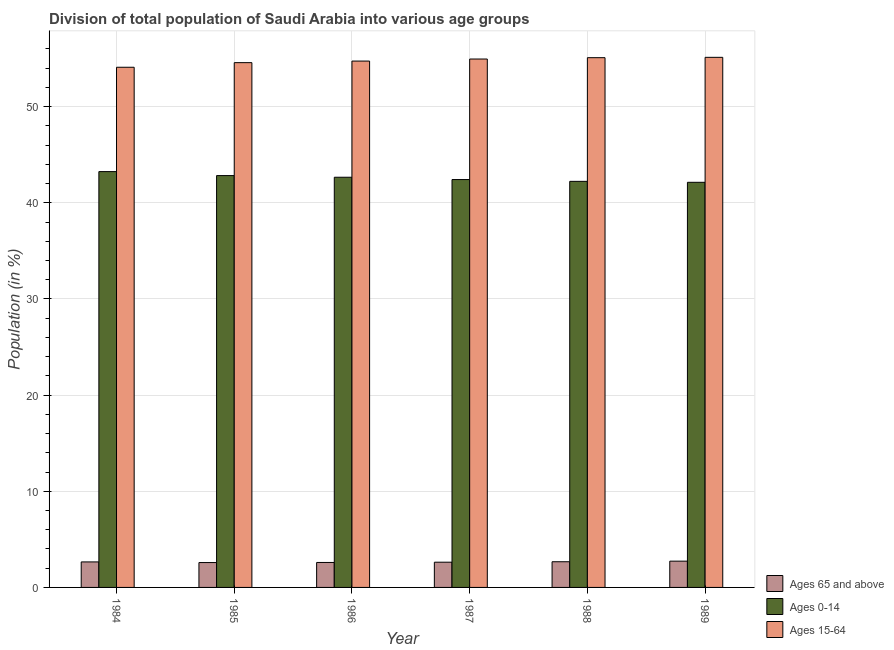Are the number of bars per tick equal to the number of legend labels?
Provide a short and direct response. Yes. How many bars are there on the 4th tick from the left?
Ensure brevity in your answer.  3. How many bars are there on the 3rd tick from the right?
Offer a very short reply. 3. In how many cases, is the number of bars for a given year not equal to the number of legend labels?
Offer a terse response. 0. What is the percentage of population within the age-group of 65 and above in 1984?
Offer a terse response. 2.65. Across all years, what is the maximum percentage of population within the age-group 0-14?
Give a very brief answer. 43.25. Across all years, what is the minimum percentage of population within the age-group 0-14?
Provide a succinct answer. 42.13. In which year was the percentage of population within the age-group 15-64 minimum?
Provide a short and direct response. 1984. What is the total percentage of population within the age-group of 65 and above in the graph?
Offer a very short reply. 15.86. What is the difference between the percentage of population within the age-group of 65 and above in 1984 and that in 1988?
Your response must be concise. -0.02. What is the difference between the percentage of population within the age-group of 65 and above in 1985 and the percentage of population within the age-group 15-64 in 1987?
Offer a terse response. -0.04. What is the average percentage of population within the age-group of 65 and above per year?
Provide a short and direct response. 2.64. In how many years, is the percentage of population within the age-group of 65 and above greater than 22 %?
Your answer should be compact. 0. What is the ratio of the percentage of population within the age-group 15-64 in 1987 to that in 1988?
Your answer should be very brief. 1. Is the difference between the percentage of population within the age-group 15-64 in 1987 and 1988 greater than the difference between the percentage of population within the age-group 0-14 in 1987 and 1988?
Your answer should be very brief. No. What is the difference between the highest and the second highest percentage of population within the age-group 15-64?
Keep it short and to the point. 0.04. What is the difference between the highest and the lowest percentage of population within the age-group 15-64?
Offer a very short reply. 1.03. In how many years, is the percentage of population within the age-group of 65 and above greater than the average percentage of population within the age-group of 65 and above taken over all years?
Give a very brief answer. 3. Is the sum of the percentage of population within the age-group 0-14 in 1987 and 1989 greater than the maximum percentage of population within the age-group of 65 and above across all years?
Make the answer very short. Yes. What does the 1st bar from the left in 1986 represents?
Make the answer very short. Ages 65 and above. What does the 1st bar from the right in 1987 represents?
Give a very brief answer. Ages 15-64. Is it the case that in every year, the sum of the percentage of population within the age-group of 65 and above and percentage of population within the age-group 0-14 is greater than the percentage of population within the age-group 15-64?
Your answer should be compact. No. Are all the bars in the graph horizontal?
Provide a succinct answer. No. Are the values on the major ticks of Y-axis written in scientific E-notation?
Your answer should be compact. No. Does the graph contain any zero values?
Make the answer very short. No. Does the graph contain grids?
Offer a very short reply. Yes. How are the legend labels stacked?
Make the answer very short. Vertical. What is the title of the graph?
Provide a short and direct response. Division of total population of Saudi Arabia into various age groups
. Does "Agricultural raw materials" appear as one of the legend labels in the graph?
Make the answer very short. No. What is the label or title of the X-axis?
Provide a succinct answer. Year. What is the Population (in %) in Ages 65 and above in 1984?
Your response must be concise. 2.65. What is the Population (in %) in Ages 0-14 in 1984?
Offer a terse response. 43.25. What is the Population (in %) of Ages 15-64 in 1984?
Offer a terse response. 54.1. What is the Population (in %) in Ages 65 and above in 1985?
Your answer should be compact. 2.59. What is the Population (in %) in Ages 0-14 in 1985?
Provide a short and direct response. 42.83. What is the Population (in %) in Ages 15-64 in 1985?
Offer a terse response. 54.58. What is the Population (in %) in Ages 65 and above in 1986?
Keep it short and to the point. 2.6. What is the Population (in %) in Ages 0-14 in 1986?
Offer a terse response. 42.66. What is the Population (in %) in Ages 15-64 in 1986?
Ensure brevity in your answer.  54.74. What is the Population (in %) in Ages 65 and above in 1987?
Offer a terse response. 2.62. What is the Population (in %) of Ages 0-14 in 1987?
Make the answer very short. 42.42. What is the Population (in %) of Ages 15-64 in 1987?
Offer a terse response. 54.96. What is the Population (in %) of Ages 65 and above in 1988?
Keep it short and to the point. 2.67. What is the Population (in %) in Ages 0-14 in 1988?
Make the answer very short. 42.23. What is the Population (in %) in Ages 15-64 in 1988?
Provide a short and direct response. 55.1. What is the Population (in %) of Ages 65 and above in 1989?
Offer a terse response. 2.73. What is the Population (in %) of Ages 0-14 in 1989?
Your answer should be compact. 42.13. What is the Population (in %) of Ages 15-64 in 1989?
Provide a succinct answer. 55.13. Across all years, what is the maximum Population (in %) of Ages 65 and above?
Your answer should be compact. 2.73. Across all years, what is the maximum Population (in %) of Ages 0-14?
Make the answer very short. 43.25. Across all years, what is the maximum Population (in %) of Ages 15-64?
Keep it short and to the point. 55.13. Across all years, what is the minimum Population (in %) of Ages 65 and above?
Offer a terse response. 2.59. Across all years, what is the minimum Population (in %) in Ages 0-14?
Offer a terse response. 42.13. Across all years, what is the minimum Population (in %) in Ages 15-64?
Your response must be concise. 54.1. What is the total Population (in %) of Ages 65 and above in the graph?
Your response must be concise. 15.86. What is the total Population (in %) in Ages 0-14 in the graph?
Your answer should be compact. 255.53. What is the total Population (in %) in Ages 15-64 in the graph?
Offer a very short reply. 328.61. What is the difference between the Population (in %) in Ages 65 and above in 1984 and that in 1985?
Your response must be concise. 0.07. What is the difference between the Population (in %) in Ages 0-14 in 1984 and that in 1985?
Give a very brief answer. 0.41. What is the difference between the Population (in %) in Ages 15-64 in 1984 and that in 1985?
Make the answer very short. -0.48. What is the difference between the Population (in %) of Ages 65 and above in 1984 and that in 1986?
Your response must be concise. 0.06. What is the difference between the Population (in %) of Ages 0-14 in 1984 and that in 1986?
Your response must be concise. 0.59. What is the difference between the Population (in %) of Ages 15-64 in 1984 and that in 1986?
Offer a terse response. -0.64. What is the difference between the Population (in %) in Ages 65 and above in 1984 and that in 1987?
Offer a terse response. 0.03. What is the difference between the Population (in %) in Ages 0-14 in 1984 and that in 1987?
Offer a terse response. 0.83. What is the difference between the Population (in %) of Ages 15-64 in 1984 and that in 1987?
Provide a succinct answer. -0.86. What is the difference between the Population (in %) of Ages 65 and above in 1984 and that in 1988?
Provide a short and direct response. -0.02. What is the difference between the Population (in %) of Ages 0-14 in 1984 and that in 1988?
Provide a succinct answer. 1.01. What is the difference between the Population (in %) in Ages 15-64 in 1984 and that in 1988?
Provide a short and direct response. -0.99. What is the difference between the Population (in %) of Ages 65 and above in 1984 and that in 1989?
Provide a short and direct response. -0.08. What is the difference between the Population (in %) in Ages 0-14 in 1984 and that in 1989?
Keep it short and to the point. 1.11. What is the difference between the Population (in %) in Ages 15-64 in 1984 and that in 1989?
Ensure brevity in your answer.  -1.03. What is the difference between the Population (in %) of Ages 65 and above in 1985 and that in 1986?
Make the answer very short. -0.01. What is the difference between the Population (in %) in Ages 0-14 in 1985 and that in 1986?
Your response must be concise. 0.17. What is the difference between the Population (in %) in Ages 15-64 in 1985 and that in 1986?
Your response must be concise. -0.16. What is the difference between the Population (in %) of Ages 65 and above in 1985 and that in 1987?
Provide a succinct answer. -0.04. What is the difference between the Population (in %) in Ages 0-14 in 1985 and that in 1987?
Ensure brevity in your answer.  0.41. What is the difference between the Population (in %) in Ages 15-64 in 1985 and that in 1987?
Make the answer very short. -0.38. What is the difference between the Population (in %) in Ages 65 and above in 1985 and that in 1988?
Your answer should be very brief. -0.08. What is the difference between the Population (in %) in Ages 0-14 in 1985 and that in 1988?
Your answer should be compact. 0.6. What is the difference between the Population (in %) in Ages 15-64 in 1985 and that in 1988?
Give a very brief answer. -0.52. What is the difference between the Population (in %) of Ages 65 and above in 1985 and that in 1989?
Provide a short and direct response. -0.15. What is the difference between the Population (in %) in Ages 0-14 in 1985 and that in 1989?
Your answer should be compact. 0.7. What is the difference between the Population (in %) of Ages 15-64 in 1985 and that in 1989?
Provide a succinct answer. -0.55. What is the difference between the Population (in %) in Ages 65 and above in 1986 and that in 1987?
Your answer should be compact. -0.03. What is the difference between the Population (in %) in Ages 0-14 in 1986 and that in 1987?
Provide a short and direct response. 0.24. What is the difference between the Population (in %) of Ages 15-64 in 1986 and that in 1987?
Give a very brief answer. -0.21. What is the difference between the Population (in %) in Ages 65 and above in 1986 and that in 1988?
Your answer should be very brief. -0.08. What is the difference between the Population (in %) of Ages 0-14 in 1986 and that in 1988?
Offer a very short reply. 0.43. What is the difference between the Population (in %) of Ages 15-64 in 1986 and that in 1988?
Ensure brevity in your answer.  -0.35. What is the difference between the Population (in %) of Ages 65 and above in 1986 and that in 1989?
Keep it short and to the point. -0.14. What is the difference between the Population (in %) in Ages 0-14 in 1986 and that in 1989?
Offer a very short reply. 0.53. What is the difference between the Population (in %) in Ages 15-64 in 1986 and that in 1989?
Your response must be concise. -0.39. What is the difference between the Population (in %) in Ages 65 and above in 1987 and that in 1988?
Ensure brevity in your answer.  -0.05. What is the difference between the Population (in %) in Ages 0-14 in 1987 and that in 1988?
Offer a very short reply. 0.19. What is the difference between the Population (in %) in Ages 15-64 in 1987 and that in 1988?
Your answer should be compact. -0.14. What is the difference between the Population (in %) in Ages 65 and above in 1987 and that in 1989?
Offer a very short reply. -0.11. What is the difference between the Population (in %) in Ages 0-14 in 1987 and that in 1989?
Keep it short and to the point. 0.28. What is the difference between the Population (in %) of Ages 15-64 in 1987 and that in 1989?
Your response must be concise. -0.18. What is the difference between the Population (in %) of Ages 65 and above in 1988 and that in 1989?
Your answer should be very brief. -0.06. What is the difference between the Population (in %) of Ages 0-14 in 1988 and that in 1989?
Make the answer very short. 0.1. What is the difference between the Population (in %) of Ages 15-64 in 1988 and that in 1989?
Give a very brief answer. -0.04. What is the difference between the Population (in %) of Ages 65 and above in 1984 and the Population (in %) of Ages 0-14 in 1985?
Your response must be concise. -40.18. What is the difference between the Population (in %) in Ages 65 and above in 1984 and the Population (in %) in Ages 15-64 in 1985?
Offer a terse response. -51.93. What is the difference between the Population (in %) of Ages 0-14 in 1984 and the Population (in %) of Ages 15-64 in 1985?
Offer a very short reply. -11.33. What is the difference between the Population (in %) of Ages 65 and above in 1984 and the Population (in %) of Ages 0-14 in 1986?
Your response must be concise. -40.01. What is the difference between the Population (in %) of Ages 65 and above in 1984 and the Population (in %) of Ages 15-64 in 1986?
Your answer should be compact. -52.09. What is the difference between the Population (in %) in Ages 0-14 in 1984 and the Population (in %) in Ages 15-64 in 1986?
Your answer should be very brief. -11.5. What is the difference between the Population (in %) of Ages 65 and above in 1984 and the Population (in %) of Ages 0-14 in 1987?
Give a very brief answer. -39.77. What is the difference between the Population (in %) of Ages 65 and above in 1984 and the Population (in %) of Ages 15-64 in 1987?
Your answer should be very brief. -52.3. What is the difference between the Population (in %) in Ages 0-14 in 1984 and the Population (in %) in Ages 15-64 in 1987?
Your answer should be very brief. -11.71. What is the difference between the Population (in %) of Ages 65 and above in 1984 and the Population (in %) of Ages 0-14 in 1988?
Your answer should be compact. -39.58. What is the difference between the Population (in %) in Ages 65 and above in 1984 and the Population (in %) in Ages 15-64 in 1988?
Provide a succinct answer. -52.44. What is the difference between the Population (in %) in Ages 0-14 in 1984 and the Population (in %) in Ages 15-64 in 1988?
Your answer should be compact. -11.85. What is the difference between the Population (in %) of Ages 65 and above in 1984 and the Population (in %) of Ages 0-14 in 1989?
Offer a terse response. -39.48. What is the difference between the Population (in %) in Ages 65 and above in 1984 and the Population (in %) in Ages 15-64 in 1989?
Ensure brevity in your answer.  -52.48. What is the difference between the Population (in %) of Ages 0-14 in 1984 and the Population (in %) of Ages 15-64 in 1989?
Your answer should be very brief. -11.89. What is the difference between the Population (in %) in Ages 65 and above in 1985 and the Population (in %) in Ages 0-14 in 1986?
Give a very brief answer. -40.07. What is the difference between the Population (in %) of Ages 65 and above in 1985 and the Population (in %) of Ages 15-64 in 1986?
Offer a terse response. -52.16. What is the difference between the Population (in %) of Ages 0-14 in 1985 and the Population (in %) of Ages 15-64 in 1986?
Offer a terse response. -11.91. What is the difference between the Population (in %) of Ages 65 and above in 1985 and the Population (in %) of Ages 0-14 in 1987?
Your answer should be compact. -39.83. What is the difference between the Population (in %) of Ages 65 and above in 1985 and the Population (in %) of Ages 15-64 in 1987?
Your answer should be compact. -52.37. What is the difference between the Population (in %) of Ages 0-14 in 1985 and the Population (in %) of Ages 15-64 in 1987?
Give a very brief answer. -12.12. What is the difference between the Population (in %) of Ages 65 and above in 1985 and the Population (in %) of Ages 0-14 in 1988?
Offer a terse response. -39.65. What is the difference between the Population (in %) in Ages 65 and above in 1985 and the Population (in %) in Ages 15-64 in 1988?
Offer a terse response. -52.51. What is the difference between the Population (in %) of Ages 0-14 in 1985 and the Population (in %) of Ages 15-64 in 1988?
Keep it short and to the point. -12.26. What is the difference between the Population (in %) in Ages 65 and above in 1985 and the Population (in %) in Ages 0-14 in 1989?
Your response must be concise. -39.55. What is the difference between the Population (in %) in Ages 65 and above in 1985 and the Population (in %) in Ages 15-64 in 1989?
Keep it short and to the point. -52.55. What is the difference between the Population (in %) in Ages 0-14 in 1985 and the Population (in %) in Ages 15-64 in 1989?
Your answer should be compact. -12.3. What is the difference between the Population (in %) in Ages 65 and above in 1986 and the Population (in %) in Ages 0-14 in 1987?
Offer a terse response. -39.82. What is the difference between the Population (in %) of Ages 65 and above in 1986 and the Population (in %) of Ages 15-64 in 1987?
Provide a short and direct response. -52.36. What is the difference between the Population (in %) in Ages 0-14 in 1986 and the Population (in %) in Ages 15-64 in 1987?
Provide a short and direct response. -12.3. What is the difference between the Population (in %) in Ages 65 and above in 1986 and the Population (in %) in Ages 0-14 in 1988?
Your response must be concise. -39.64. What is the difference between the Population (in %) of Ages 65 and above in 1986 and the Population (in %) of Ages 15-64 in 1988?
Make the answer very short. -52.5. What is the difference between the Population (in %) in Ages 0-14 in 1986 and the Population (in %) in Ages 15-64 in 1988?
Your response must be concise. -12.43. What is the difference between the Population (in %) in Ages 65 and above in 1986 and the Population (in %) in Ages 0-14 in 1989?
Make the answer very short. -39.54. What is the difference between the Population (in %) of Ages 65 and above in 1986 and the Population (in %) of Ages 15-64 in 1989?
Your answer should be very brief. -52.54. What is the difference between the Population (in %) of Ages 0-14 in 1986 and the Population (in %) of Ages 15-64 in 1989?
Your answer should be compact. -12.47. What is the difference between the Population (in %) of Ages 65 and above in 1987 and the Population (in %) of Ages 0-14 in 1988?
Provide a succinct answer. -39.61. What is the difference between the Population (in %) in Ages 65 and above in 1987 and the Population (in %) in Ages 15-64 in 1988?
Give a very brief answer. -52.47. What is the difference between the Population (in %) in Ages 0-14 in 1987 and the Population (in %) in Ages 15-64 in 1988?
Provide a short and direct response. -12.68. What is the difference between the Population (in %) in Ages 65 and above in 1987 and the Population (in %) in Ages 0-14 in 1989?
Provide a succinct answer. -39.51. What is the difference between the Population (in %) of Ages 65 and above in 1987 and the Population (in %) of Ages 15-64 in 1989?
Offer a very short reply. -52.51. What is the difference between the Population (in %) in Ages 0-14 in 1987 and the Population (in %) in Ages 15-64 in 1989?
Provide a succinct answer. -12.71. What is the difference between the Population (in %) in Ages 65 and above in 1988 and the Population (in %) in Ages 0-14 in 1989?
Your response must be concise. -39.46. What is the difference between the Population (in %) of Ages 65 and above in 1988 and the Population (in %) of Ages 15-64 in 1989?
Your answer should be compact. -52.46. What is the difference between the Population (in %) of Ages 0-14 in 1988 and the Population (in %) of Ages 15-64 in 1989?
Your response must be concise. -12.9. What is the average Population (in %) in Ages 65 and above per year?
Your response must be concise. 2.64. What is the average Population (in %) of Ages 0-14 per year?
Provide a succinct answer. 42.59. What is the average Population (in %) in Ages 15-64 per year?
Offer a terse response. 54.77. In the year 1984, what is the difference between the Population (in %) in Ages 65 and above and Population (in %) in Ages 0-14?
Ensure brevity in your answer.  -40.59. In the year 1984, what is the difference between the Population (in %) of Ages 65 and above and Population (in %) of Ages 15-64?
Provide a short and direct response. -51.45. In the year 1984, what is the difference between the Population (in %) of Ages 0-14 and Population (in %) of Ages 15-64?
Your response must be concise. -10.85. In the year 1985, what is the difference between the Population (in %) of Ages 65 and above and Population (in %) of Ages 0-14?
Provide a succinct answer. -40.25. In the year 1985, what is the difference between the Population (in %) in Ages 65 and above and Population (in %) in Ages 15-64?
Keep it short and to the point. -51.99. In the year 1985, what is the difference between the Population (in %) of Ages 0-14 and Population (in %) of Ages 15-64?
Offer a very short reply. -11.75. In the year 1986, what is the difference between the Population (in %) of Ages 65 and above and Population (in %) of Ages 0-14?
Your answer should be compact. -40.06. In the year 1986, what is the difference between the Population (in %) in Ages 65 and above and Population (in %) in Ages 15-64?
Provide a succinct answer. -52.15. In the year 1986, what is the difference between the Population (in %) in Ages 0-14 and Population (in %) in Ages 15-64?
Provide a short and direct response. -12.08. In the year 1987, what is the difference between the Population (in %) of Ages 65 and above and Population (in %) of Ages 0-14?
Give a very brief answer. -39.79. In the year 1987, what is the difference between the Population (in %) of Ages 65 and above and Population (in %) of Ages 15-64?
Provide a short and direct response. -52.33. In the year 1987, what is the difference between the Population (in %) of Ages 0-14 and Population (in %) of Ages 15-64?
Your answer should be very brief. -12.54. In the year 1988, what is the difference between the Population (in %) of Ages 65 and above and Population (in %) of Ages 0-14?
Ensure brevity in your answer.  -39.56. In the year 1988, what is the difference between the Population (in %) in Ages 65 and above and Population (in %) in Ages 15-64?
Provide a succinct answer. -52.42. In the year 1988, what is the difference between the Population (in %) of Ages 0-14 and Population (in %) of Ages 15-64?
Ensure brevity in your answer.  -12.86. In the year 1989, what is the difference between the Population (in %) of Ages 65 and above and Population (in %) of Ages 0-14?
Your answer should be very brief. -39.4. In the year 1989, what is the difference between the Population (in %) of Ages 65 and above and Population (in %) of Ages 15-64?
Your response must be concise. -52.4. In the year 1989, what is the difference between the Population (in %) in Ages 0-14 and Population (in %) in Ages 15-64?
Provide a short and direct response. -13. What is the ratio of the Population (in %) in Ages 65 and above in 1984 to that in 1985?
Provide a succinct answer. 1.03. What is the ratio of the Population (in %) in Ages 0-14 in 1984 to that in 1985?
Make the answer very short. 1.01. What is the ratio of the Population (in %) in Ages 15-64 in 1984 to that in 1985?
Keep it short and to the point. 0.99. What is the ratio of the Population (in %) of Ages 65 and above in 1984 to that in 1986?
Your answer should be compact. 1.02. What is the ratio of the Population (in %) of Ages 0-14 in 1984 to that in 1986?
Your answer should be compact. 1.01. What is the ratio of the Population (in %) of Ages 15-64 in 1984 to that in 1986?
Your answer should be compact. 0.99. What is the ratio of the Population (in %) in Ages 65 and above in 1984 to that in 1987?
Offer a terse response. 1.01. What is the ratio of the Population (in %) of Ages 0-14 in 1984 to that in 1987?
Ensure brevity in your answer.  1.02. What is the ratio of the Population (in %) of Ages 15-64 in 1984 to that in 1987?
Make the answer very short. 0.98. What is the ratio of the Population (in %) of Ages 65 and above in 1984 to that in 1988?
Your response must be concise. 0.99. What is the ratio of the Population (in %) in Ages 15-64 in 1984 to that in 1988?
Make the answer very short. 0.98. What is the ratio of the Population (in %) of Ages 65 and above in 1984 to that in 1989?
Offer a terse response. 0.97. What is the ratio of the Population (in %) in Ages 0-14 in 1984 to that in 1989?
Keep it short and to the point. 1.03. What is the ratio of the Population (in %) of Ages 15-64 in 1984 to that in 1989?
Ensure brevity in your answer.  0.98. What is the ratio of the Population (in %) in Ages 65 and above in 1985 to that in 1986?
Provide a succinct answer. 1. What is the ratio of the Population (in %) in Ages 15-64 in 1985 to that in 1986?
Provide a short and direct response. 1. What is the ratio of the Population (in %) of Ages 65 and above in 1985 to that in 1987?
Offer a very short reply. 0.99. What is the ratio of the Population (in %) of Ages 0-14 in 1985 to that in 1987?
Make the answer very short. 1.01. What is the ratio of the Population (in %) in Ages 15-64 in 1985 to that in 1987?
Your answer should be very brief. 0.99. What is the ratio of the Population (in %) in Ages 65 and above in 1985 to that in 1988?
Provide a succinct answer. 0.97. What is the ratio of the Population (in %) in Ages 0-14 in 1985 to that in 1988?
Your answer should be compact. 1.01. What is the ratio of the Population (in %) of Ages 15-64 in 1985 to that in 1988?
Your response must be concise. 0.99. What is the ratio of the Population (in %) in Ages 65 and above in 1985 to that in 1989?
Ensure brevity in your answer.  0.95. What is the ratio of the Population (in %) in Ages 0-14 in 1985 to that in 1989?
Provide a succinct answer. 1.02. What is the ratio of the Population (in %) of Ages 15-64 in 1985 to that in 1989?
Provide a short and direct response. 0.99. What is the ratio of the Population (in %) of Ages 65 and above in 1986 to that in 1987?
Offer a terse response. 0.99. What is the ratio of the Population (in %) in Ages 0-14 in 1986 to that in 1987?
Provide a succinct answer. 1.01. What is the ratio of the Population (in %) in Ages 15-64 in 1986 to that in 1987?
Give a very brief answer. 1. What is the ratio of the Population (in %) of Ages 65 and above in 1986 to that in 1988?
Offer a terse response. 0.97. What is the ratio of the Population (in %) of Ages 15-64 in 1986 to that in 1988?
Your answer should be compact. 0.99. What is the ratio of the Population (in %) in Ages 65 and above in 1986 to that in 1989?
Ensure brevity in your answer.  0.95. What is the ratio of the Population (in %) in Ages 0-14 in 1986 to that in 1989?
Your response must be concise. 1.01. What is the ratio of the Population (in %) in Ages 15-64 in 1986 to that in 1989?
Your answer should be compact. 0.99. What is the ratio of the Population (in %) in Ages 65 and above in 1987 to that in 1988?
Provide a short and direct response. 0.98. What is the ratio of the Population (in %) in Ages 0-14 in 1987 to that in 1988?
Ensure brevity in your answer.  1. What is the ratio of the Population (in %) of Ages 15-64 in 1987 to that in 1988?
Provide a short and direct response. 1. What is the ratio of the Population (in %) of Ages 65 and above in 1987 to that in 1989?
Provide a short and direct response. 0.96. What is the ratio of the Population (in %) of Ages 0-14 in 1987 to that in 1989?
Provide a short and direct response. 1.01. What is the ratio of the Population (in %) of Ages 15-64 in 1987 to that in 1989?
Keep it short and to the point. 1. What is the ratio of the Population (in %) in Ages 65 and above in 1988 to that in 1989?
Provide a short and direct response. 0.98. What is the ratio of the Population (in %) in Ages 0-14 in 1988 to that in 1989?
Offer a terse response. 1. What is the ratio of the Population (in %) in Ages 15-64 in 1988 to that in 1989?
Provide a short and direct response. 1. What is the difference between the highest and the second highest Population (in %) in Ages 65 and above?
Offer a terse response. 0.06. What is the difference between the highest and the second highest Population (in %) in Ages 0-14?
Make the answer very short. 0.41. What is the difference between the highest and the second highest Population (in %) in Ages 15-64?
Ensure brevity in your answer.  0.04. What is the difference between the highest and the lowest Population (in %) in Ages 65 and above?
Make the answer very short. 0.15. What is the difference between the highest and the lowest Population (in %) of Ages 0-14?
Provide a succinct answer. 1.11. What is the difference between the highest and the lowest Population (in %) in Ages 15-64?
Offer a very short reply. 1.03. 